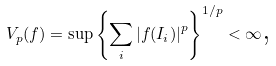<formula> <loc_0><loc_0><loc_500><loc_500>V _ { p } ( f ) = \sup \left \{ \underset { i } { \sum } \left | f ( I _ { i } ) \right | ^ { p } \right \} ^ { 1 / p } < \infty \text {,}</formula> 